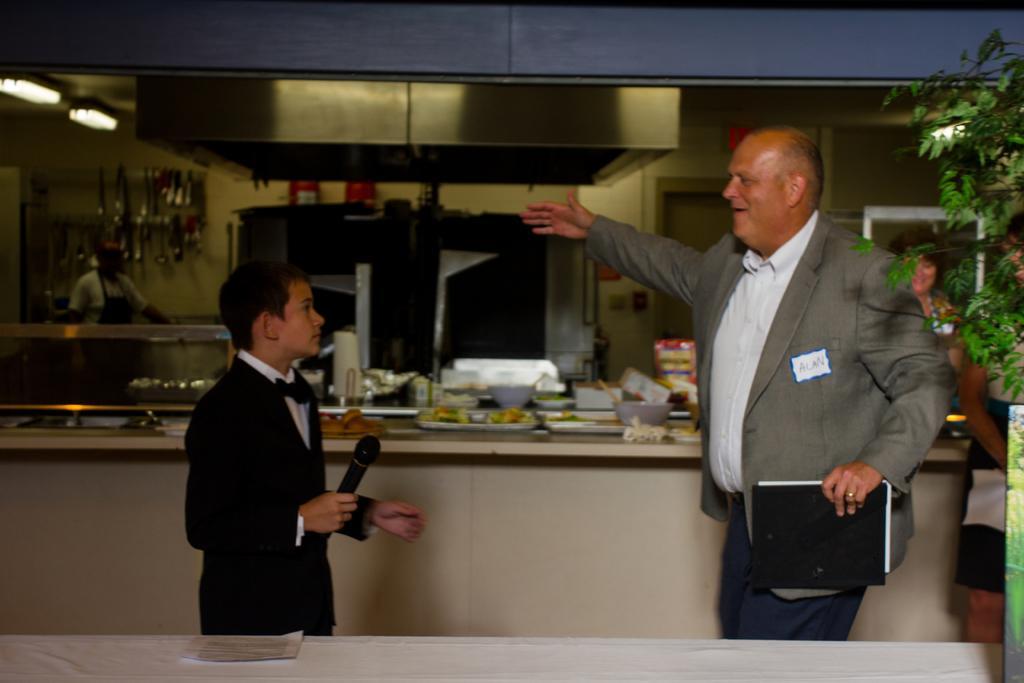Please provide a concise description of this image. Here we can see two persons. A person is holding a book with his hand and other person is holding a mike. In the background we can see plates, bowls, lights, food items and a person. There is a wall. 